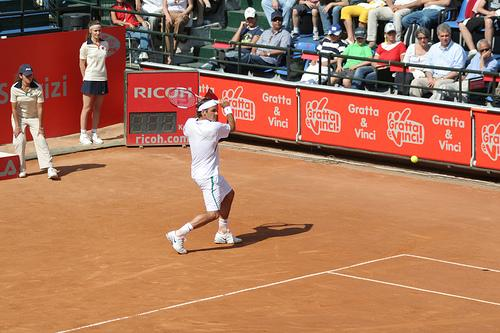Why is the man swinging his arms? Please explain your reasoning. swatting ball. The man is swinging his arms so he can hit the tennis ball back over the net. 